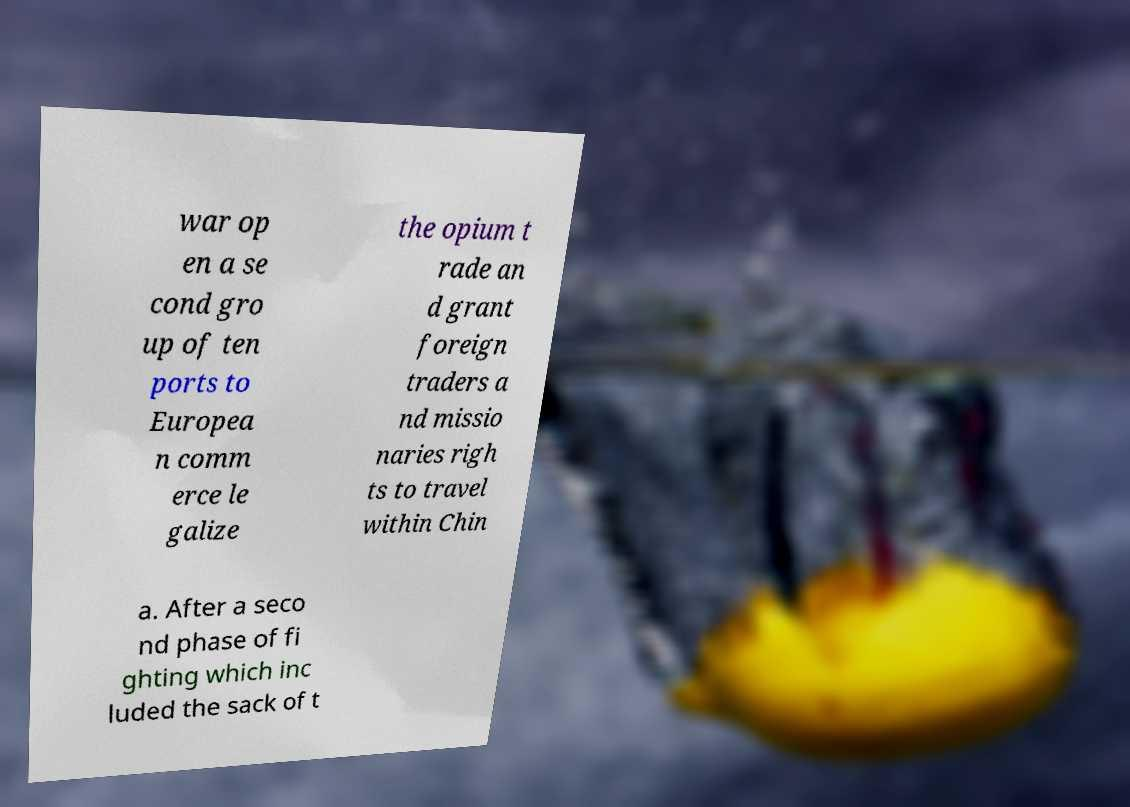What messages or text are displayed in this image? I need them in a readable, typed format. war op en a se cond gro up of ten ports to Europea n comm erce le galize the opium t rade an d grant foreign traders a nd missio naries righ ts to travel within Chin a. After a seco nd phase of fi ghting which inc luded the sack of t 